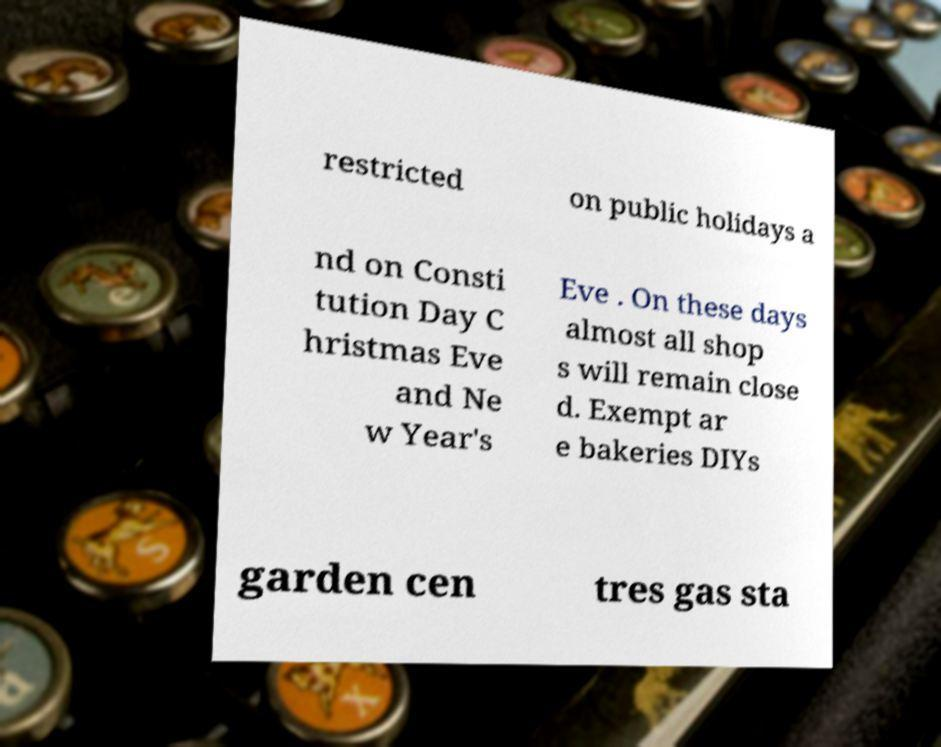For documentation purposes, I need the text within this image transcribed. Could you provide that? restricted on public holidays a nd on Consti tution Day C hristmas Eve and Ne w Year's Eve . On these days almost all shop s will remain close d. Exempt ar e bakeries DIYs garden cen tres gas sta 